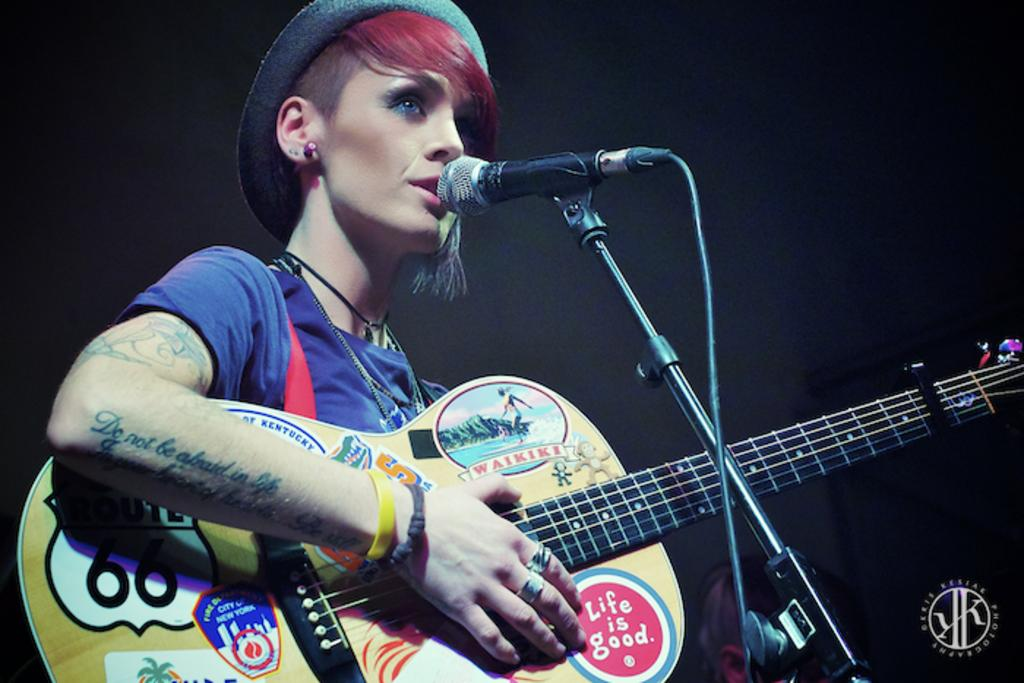Who is the main subject in the image? There is a lady in the image. What is the lady doing in the image? The lady is singing in the image. What object is in front of the lady? There is a microphone in front of the lady. What color is the lady's t-shirt? The lady is wearing a blue t-shirt. What accessory is the lady wearing on her head? The lady is wearing a hat. What musical instrument is the lady playing? The lady is playing a guitar. How would you describe the lighting in the image? The background of the image is dark. Where is the wrench located in the image? There is no wrench present in the image. What type of room is depicted in the image? The image does not show a room; it is focused on the lady and her performance. 